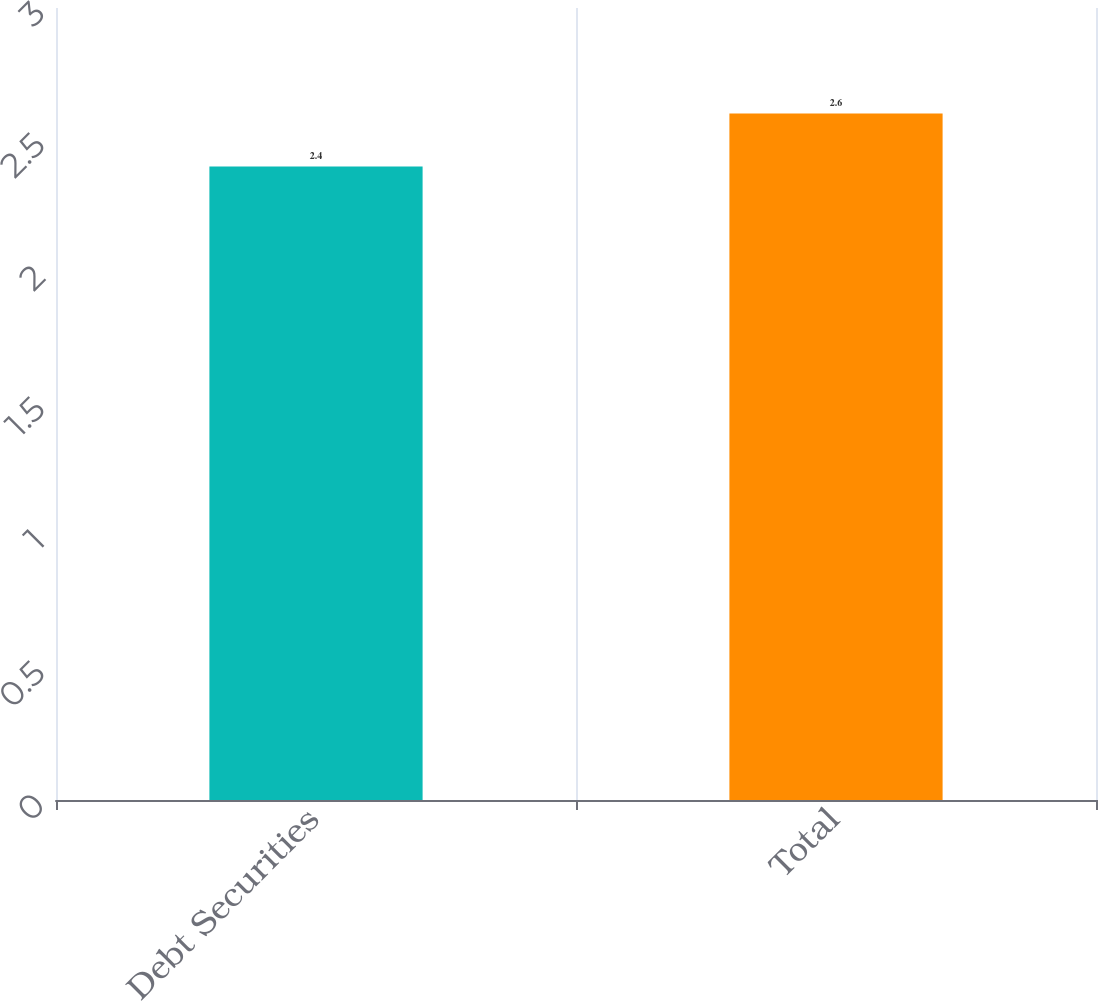Convert chart to OTSL. <chart><loc_0><loc_0><loc_500><loc_500><bar_chart><fcel>Debt Securities<fcel>Total<nl><fcel>2.4<fcel>2.6<nl></chart> 